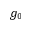Convert formula to latex. <formula><loc_0><loc_0><loc_500><loc_500>g _ { 0 }</formula> 